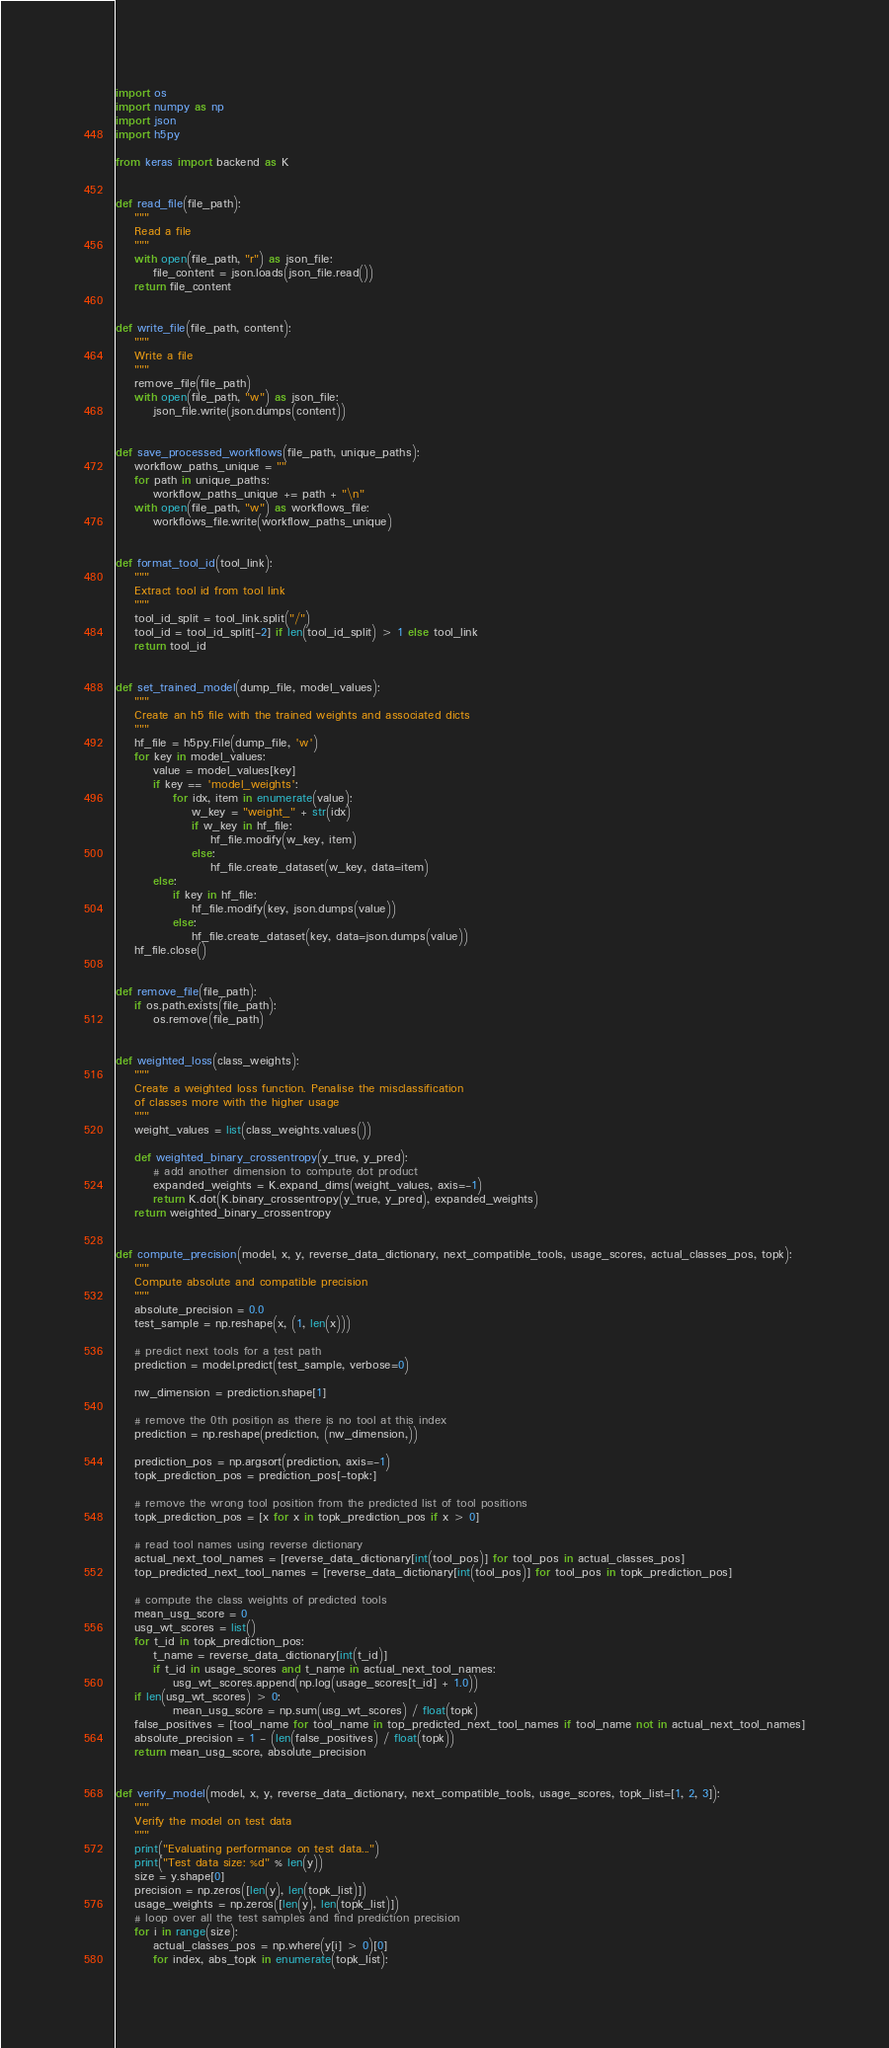<code> <loc_0><loc_0><loc_500><loc_500><_Python_>import os
import numpy as np
import json
import h5py

from keras import backend as K


def read_file(file_path):
    """
    Read a file
    """
    with open(file_path, "r") as json_file:
        file_content = json.loads(json_file.read())
    return file_content


def write_file(file_path, content):
    """
    Write a file
    """
    remove_file(file_path)
    with open(file_path, "w") as json_file:
        json_file.write(json.dumps(content))


def save_processed_workflows(file_path, unique_paths):
    workflow_paths_unique = ""
    for path in unique_paths:
        workflow_paths_unique += path + "\n"
    with open(file_path, "w") as workflows_file:
        workflows_file.write(workflow_paths_unique)


def format_tool_id(tool_link):
    """
    Extract tool id from tool link
    """
    tool_id_split = tool_link.split("/")
    tool_id = tool_id_split[-2] if len(tool_id_split) > 1 else tool_link
    return tool_id


def set_trained_model(dump_file, model_values):
    """
    Create an h5 file with the trained weights and associated dicts
    """
    hf_file = h5py.File(dump_file, 'w')
    for key in model_values:
        value = model_values[key]
        if key == 'model_weights':
            for idx, item in enumerate(value):
                w_key = "weight_" + str(idx)
                if w_key in hf_file:
                    hf_file.modify(w_key, item)
                else:
                    hf_file.create_dataset(w_key, data=item)
        else:
            if key in hf_file:
                hf_file.modify(key, json.dumps(value))
            else:
                hf_file.create_dataset(key, data=json.dumps(value))
    hf_file.close()


def remove_file(file_path):
    if os.path.exists(file_path):
        os.remove(file_path)


def weighted_loss(class_weights):
    """
    Create a weighted loss function. Penalise the misclassification
    of classes more with the higher usage
    """
    weight_values = list(class_weights.values())

    def weighted_binary_crossentropy(y_true, y_pred):
        # add another dimension to compute dot product
        expanded_weights = K.expand_dims(weight_values, axis=-1)
        return K.dot(K.binary_crossentropy(y_true, y_pred), expanded_weights)
    return weighted_binary_crossentropy


def compute_precision(model, x, y, reverse_data_dictionary, next_compatible_tools, usage_scores, actual_classes_pos, topk):
    """
    Compute absolute and compatible precision
    """
    absolute_precision = 0.0
    test_sample = np.reshape(x, (1, len(x)))

    # predict next tools for a test path
    prediction = model.predict(test_sample, verbose=0)

    nw_dimension = prediction.shape[1]

    # remove the 0th position as there is no tool at this index
    prediction = np.reshape(prediction, (nw_dimension,))

    prediction_pos = np.argsort(prediction, axis=-1)
    topk_prediction_pos = prediction_pos[-topk:]

    # remove the wrong tool position from the predicted list of tool positions
    topk_prediction_pos = [x for x in topk_prediction_pos if x > 0]

    # read tool names using reverse dictionary
    actual_next_tool_names = [reverse_data_dictionary[int(tool_pos)] for tool_pos in actual_classes_pos]
    top_predicted_next_tool_names = [reverse_data_dictionary[int(tool_pos)] for tool_pos in topk_prediction_pos]

    # compute the class weights of predicted tools
    mean_usg_score = 0
    usg_wt_scores = list()
    for t_id in topk_prediction_pos:
        t_name = reverse_data_dictionary[int(t_id)]
        if t_id in usage_scores and t_name in actual_next_tool_names:
            usg_wt_scores.append(np.log(usage_scores[t_id] + 1.0))
    if len(usg_wt_scores) > 0:
            mean_usg_score = np.sum(usg_wt_scores) / float(topk)
    false_positives = [tool_name for tool_name in top_predicted_next_tool_names if tool_name not in actual_next_tool_names]
    absolute_precision = 1 - (len(false_positives) / float(topk))
    return mean_usg_score, absolute_precision


def verify_model(model, x, y, reverse_data_dictionary, next_compatible_tools, usage_scores, topk_list=[1, 2, 3]):
    """
    Verify the model on test data
    """
    print("Evaluating performance on test data...")
    print("Test data size: %d" % len(y))
    size = y.shape[0]
    precision = np.zeros([len(y), len(topk_list)])
    usage_weights = np.zeros([len(y), len(topk_list)])
    # loop over all the test samples and find prediction precision
    for i in range(size):
        actual_classes_pos = np.where(y[i] > 0)[0]
        for index, abs_topk in enumerate(topk_list):</code> 